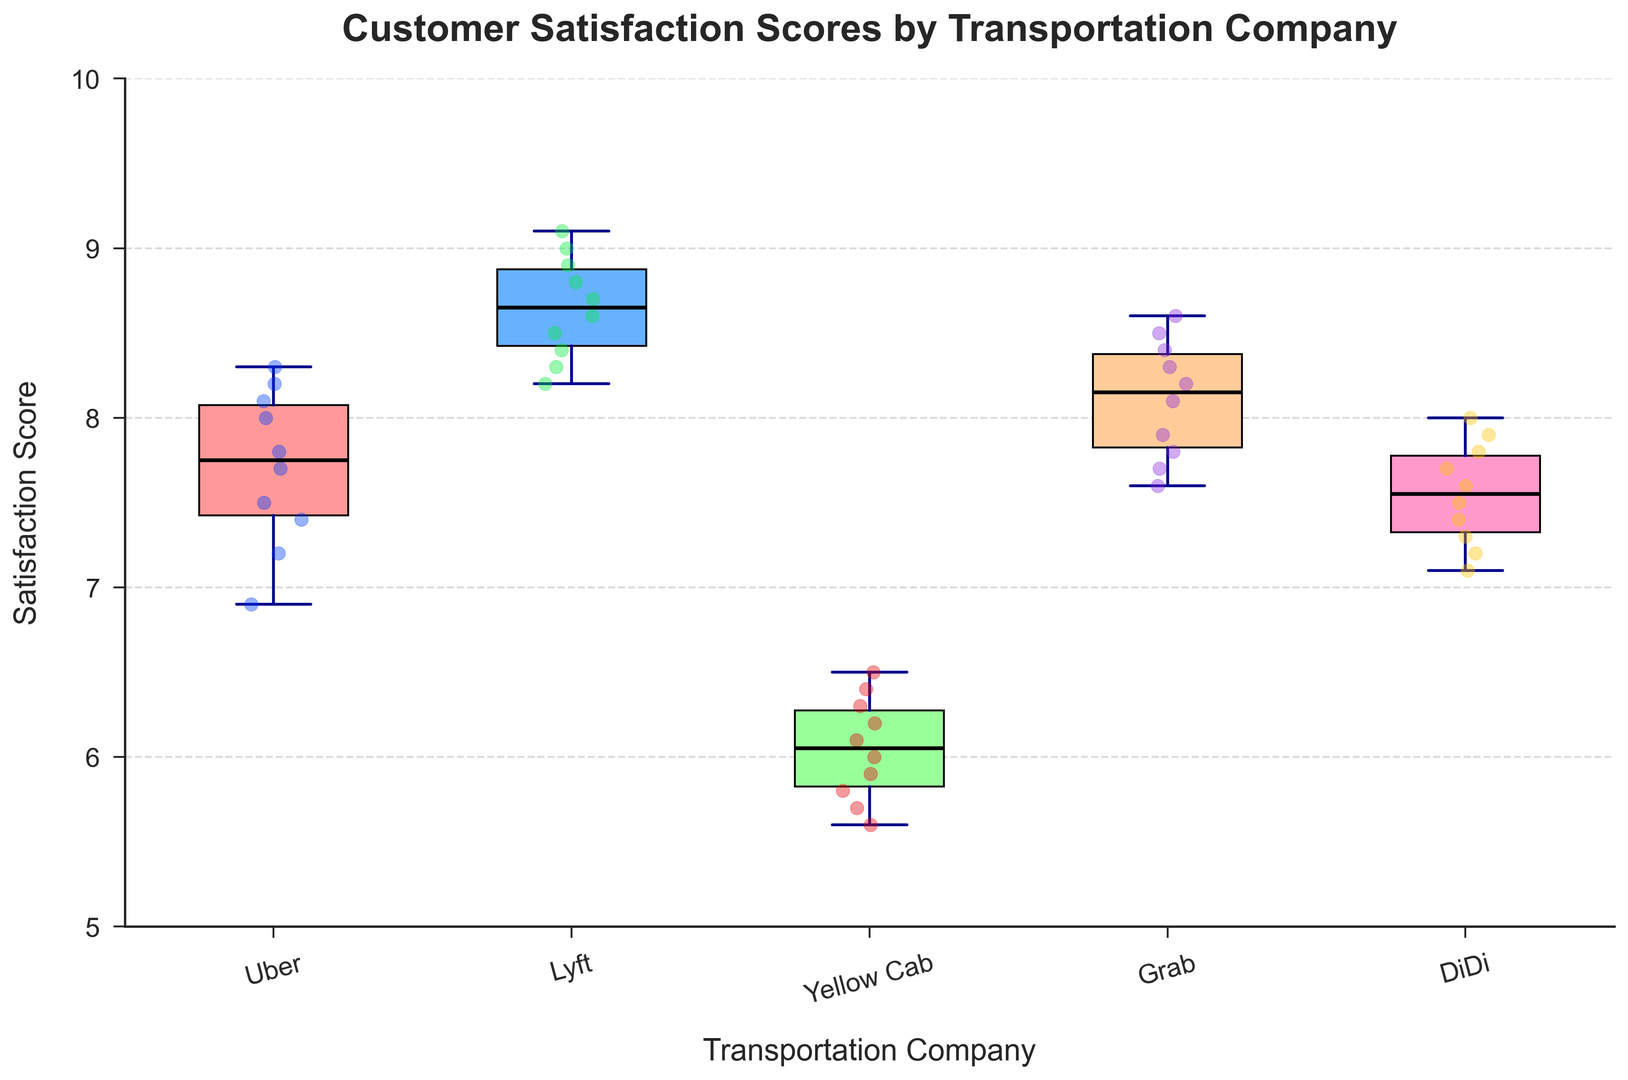Which company has the highest median satisfaction score? To find the company with the highest median satisfaction score, look for the middle line inside each box, which represents the median. The box for Lyft has the highest median line.
Answer: Lyft Which company has the lowest satisfaction score outlier? Outliers are typically represented by dots outside the whiskers. The company with the lowest outlier can be identified as Yellow Cab since it extends furthest down.
Answer: Yellow Cab What's the interquartile range (IQR) for Uber? The IQR is calculated as the difference between the upper quartile (top edge of the box) and the lower quartile (bottom edge of the box). For Uber, the top edge is around 8.1, and the bottom edge is around 7.2. So, the IQR = 8.1 - 7.2 = 0.9.
Answer: 0.9 Which companies have a median satisfaction score above 8? Identify the companies where the median line (inside the box) is above the satisfaction score of 8. Both Lyft and Grab fall into this category.
Answer: Lyft, Grab How does the spread of data for DiDi compare to LYFT? The spread of data can be analyzed by looking at the range of the whiskers and the height of the box. DiDi has a narrower spread, with a smaller range between its whiskers, compared to Lyft, which has a wider spread.
Answer: DiDi has a narrower spread What is the range of satisfaction scores for Yellow Cab? Identify the minimum and maximum ends of the whiskers for Yellow Cab. The minimum is around 5.6, and the maximum is around 6.5. So, the range = 6.5 - 5.6 = 0.9.
Answer: 0.9 Which company shows the most consistency in driver attitude based on satisfaction scores? Consistency can be gauged by the range and the IQR. The company with the smallest IQR and range would be the most consistent. DiDi seems to have the smallest IQR and a narrow range, indicating high consistency.
Answer: DiDi Do any companies have outliers above the upper quartile? If so, which ones? Outliers above the upper quartile would be indicated by dots above the top whisker. There are no visible dots above the top whisker for any company, indicating no such high outliers.
Answer: No companies have high outliers 